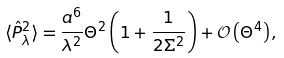Convert formula to latex. <formula><loc_0><loc_0><loc_500><loc_500>\langle \hat { P } _ { \lambda } ^ { 2 } \rangle = \frac { a ^ { 6 } } { \lambda ^ { 2 } } \Theta ^ { 2 } \left ( 1 + \frac { 1 } { 2 \Sigma ^ { 2 } } \right ) + \mathcal { O } \left ( \Theta ^ { 4 } \right ) ,</formula> 